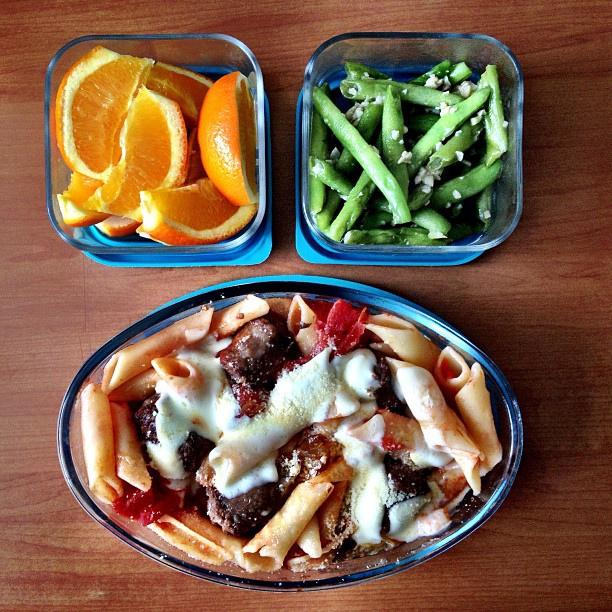What type of pasta meal is on the table?
Concise answer only. Penne. Is this a Japanese meal?
Short answer required. No. What color is the dish on the upper left?
Keep it brief. Orange. Are there green beans on the table?
Write a very short answer. Yes. 